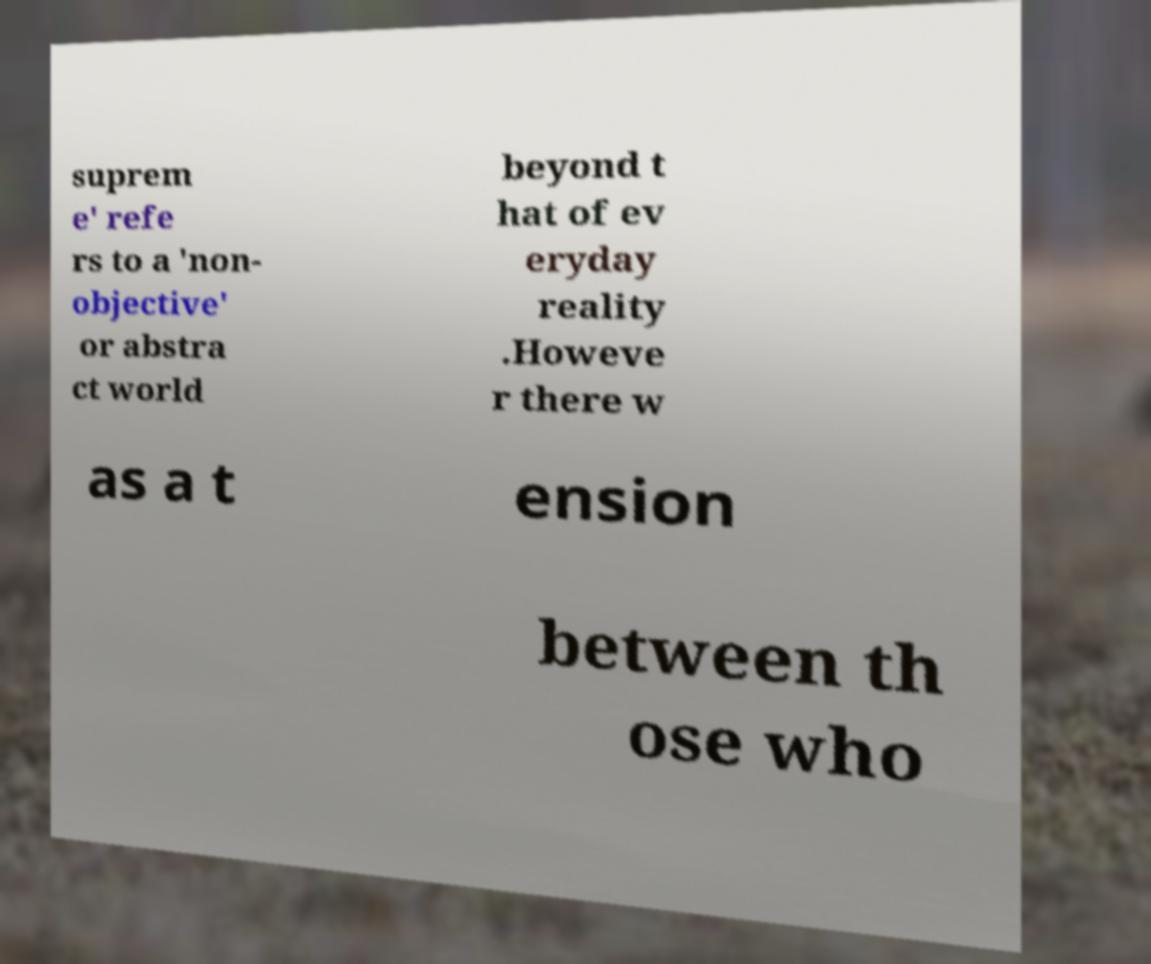Could you extract and type out the text from this image? suprem e' refe rs to a 'non- objective' or abstra ct world beyond t hat of ev eryday reality .Howeve r there w as a t ension between th ose who 